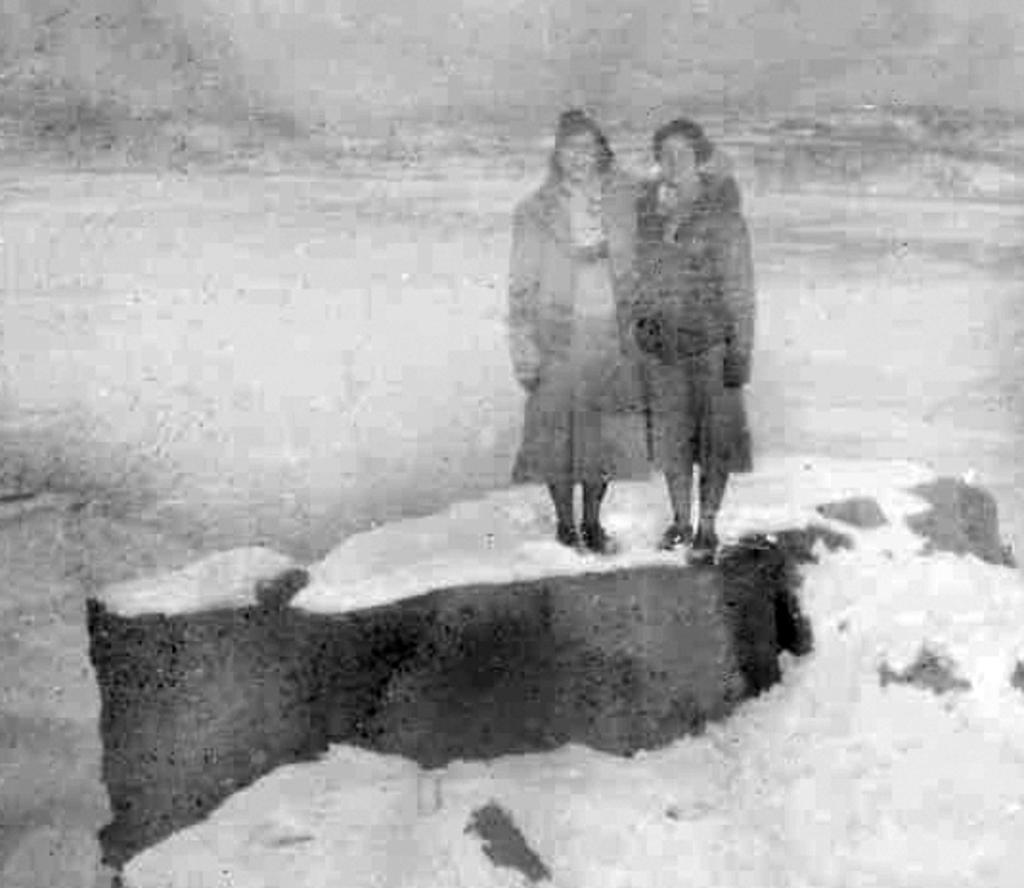How many people are in the image? There are two persons in the image. What is the surface that the persons are standing on? The persons are on a white surface. What colors are predominant in the background of the image? The background of the image is grey and white. What type of lumber is being used by the persons in the image? There is no lumber present in the image; the persons are standing on a white surface. How much lead can be seen in the image? There is no lead visible in the image. 